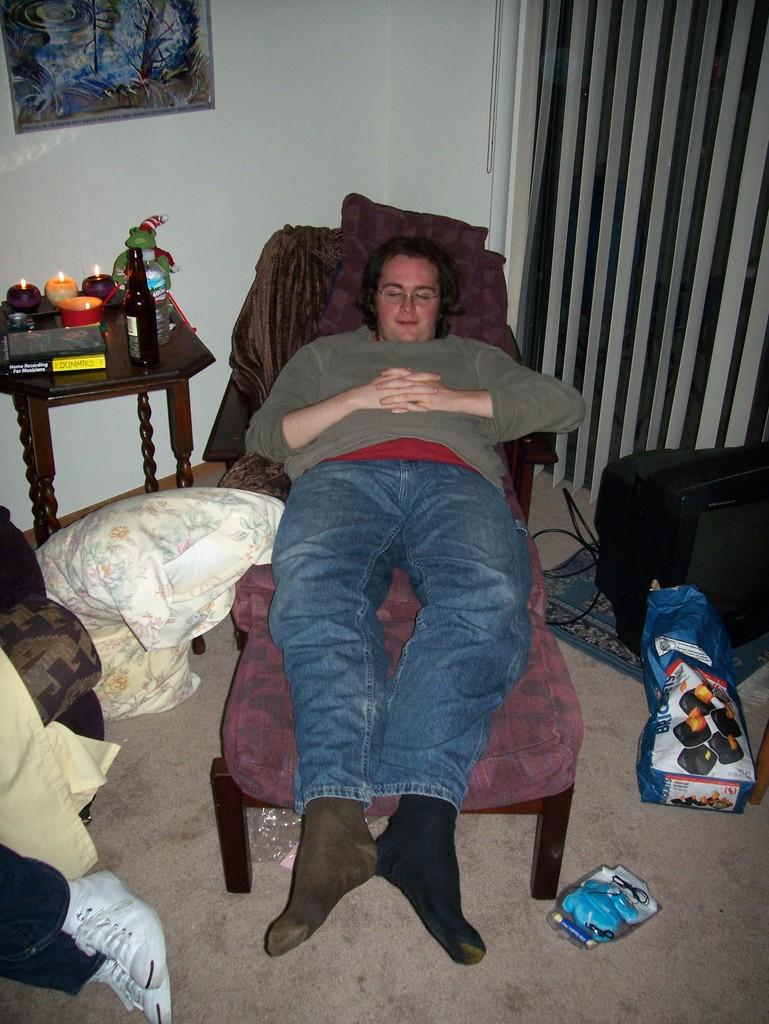What is the person in the image doing? The person is lying on a chair. What object is beside the chair? There is a pillow beside the chair. What items can be seen on the table? There are candles, a book, and bottles on the table. What is hanging on the wall? There is a picture on the wall. What is on the carpet? There is a television on the carpet. How many trees are visible in the image? There are no trees visible in the image. What type of wool is being used to make the person's clothing in the image? There is no information about the person's clothing or the use of wool in the image. 